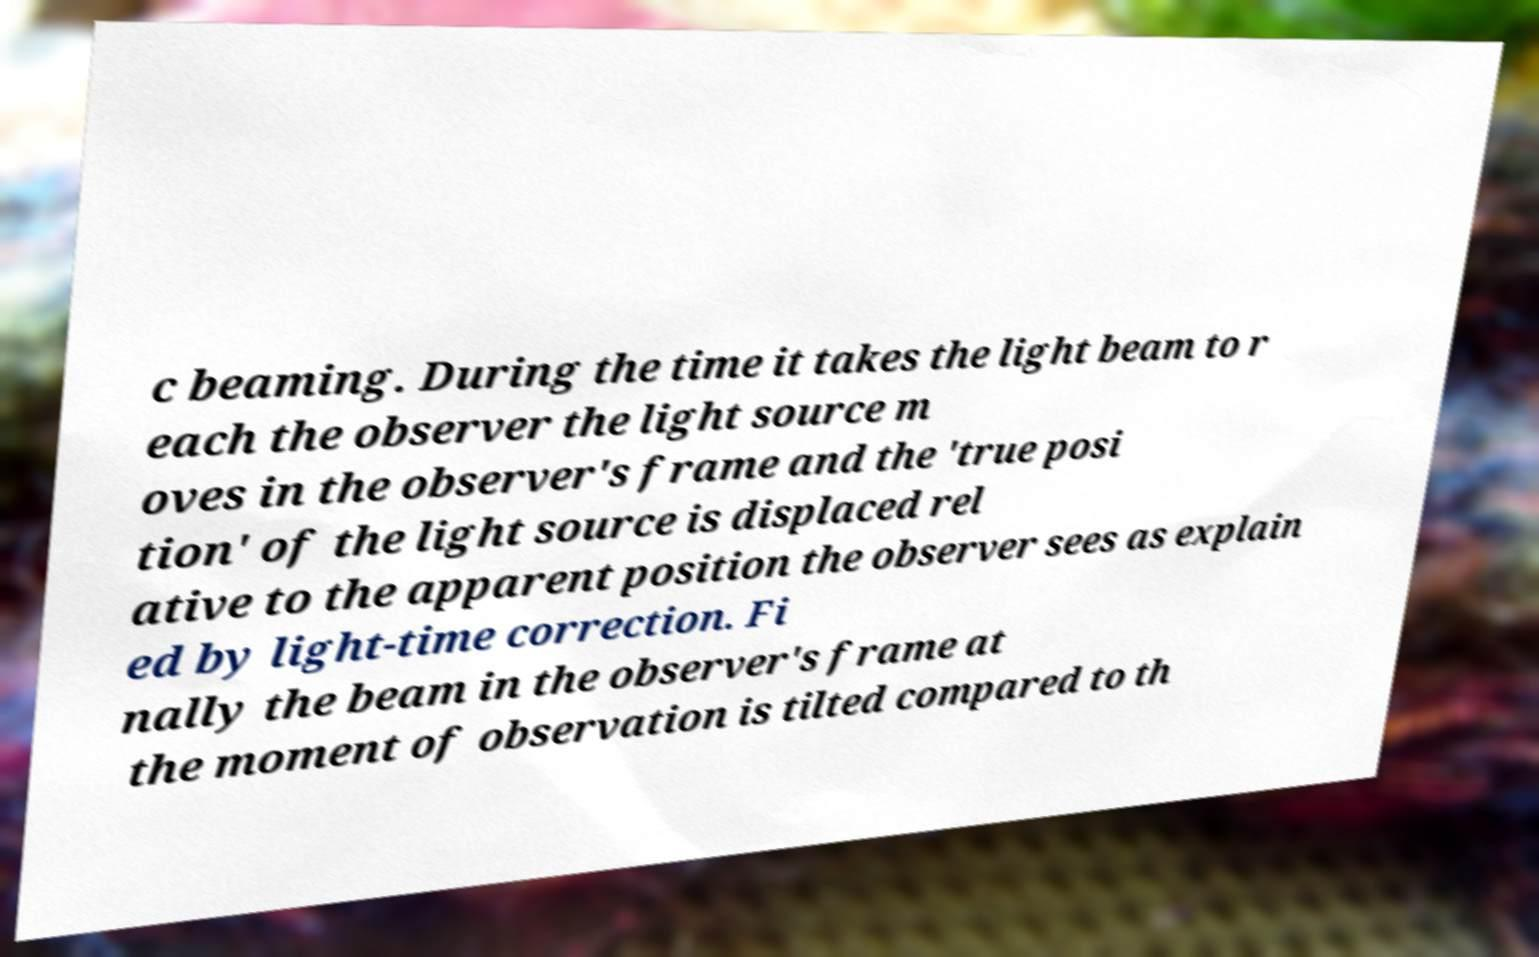What messages or text are displayed in this image? I need them in a readable, typed format. c beaming. During the time it takes the light beam to r each the observer the light source m oves in the observer's frame and the 'true posi tion' of the light source is displaced rel ative to the apparent position the observer sees as explain ed by light-time correction. Fi nally the beam in the observer's frame at the moment of observation is tilted compared to th 